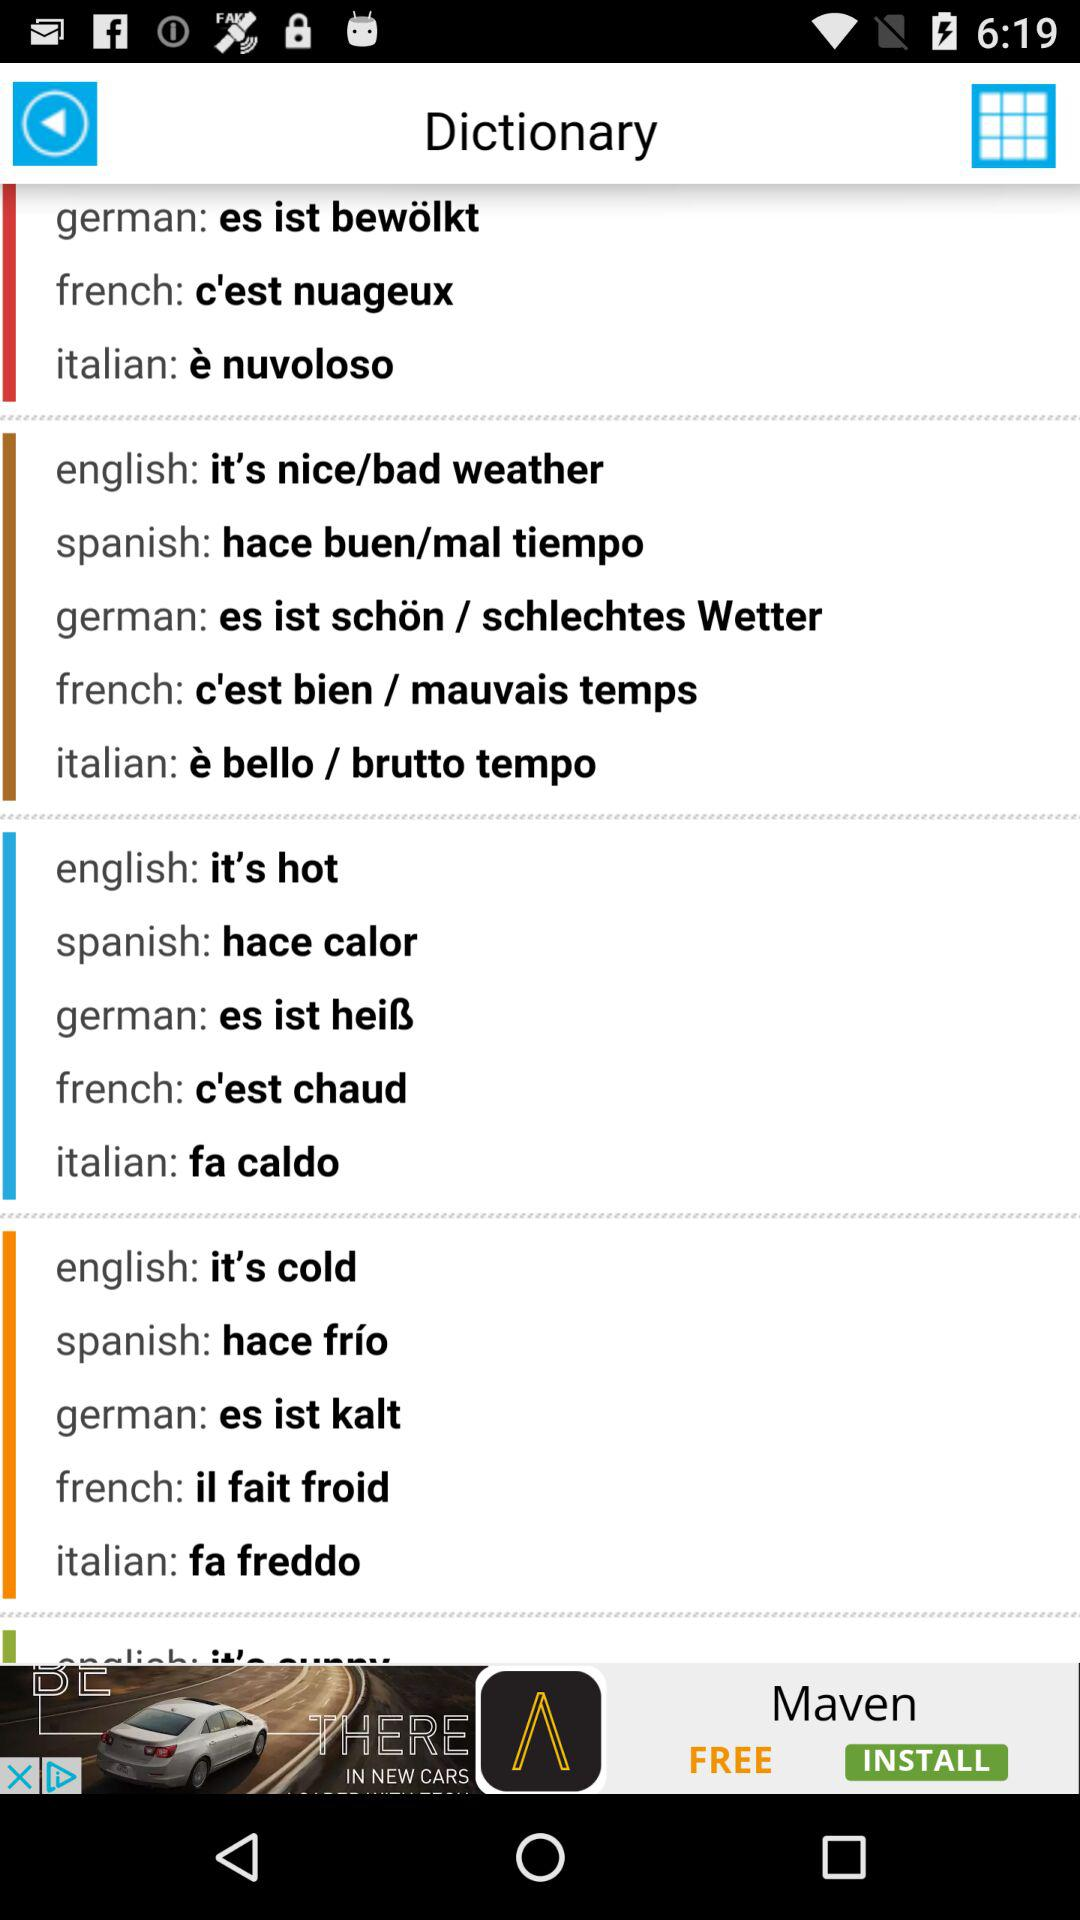What is the application name? The application name is "Dictionary". 